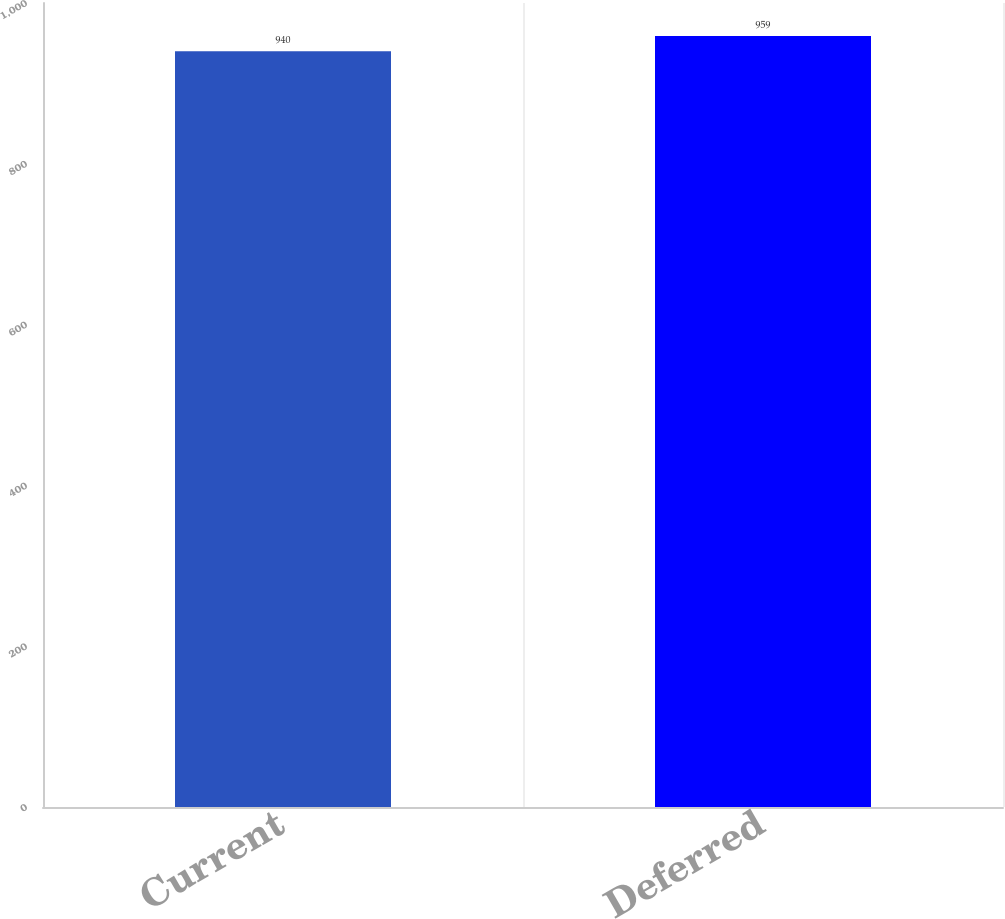<chart> <loc_0><loc_0><loc_500><loc_500><bar_chart><fcel>Current<fcel>Deferred<nl><fcel>940<fcel>959<nl></chart> 